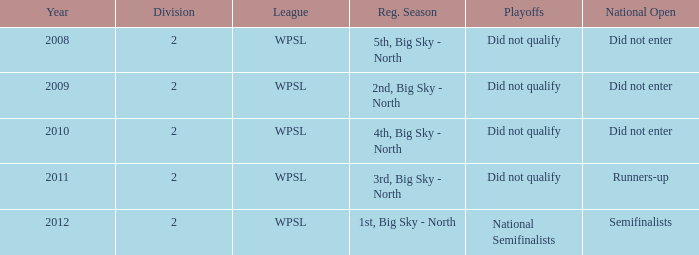What is the topmost number of divisions cited? 2.0. 